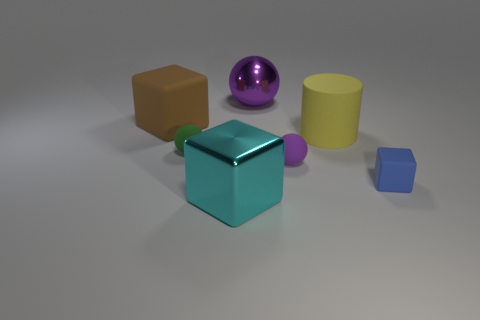Add 2 gray balls. How many objects exist? 9 Subtract all cylinders. How many objects are left? 6 Add 1 brown matte objects. How many brown matte objects exist? 2 Subtract 0 red cylinders. How many objects are left? 7 Subtract all shiny spheres. Subtract all big shiny balls. How many objects are left? 5 Add 1 matte spheres. How many matte spheres are left? 3 